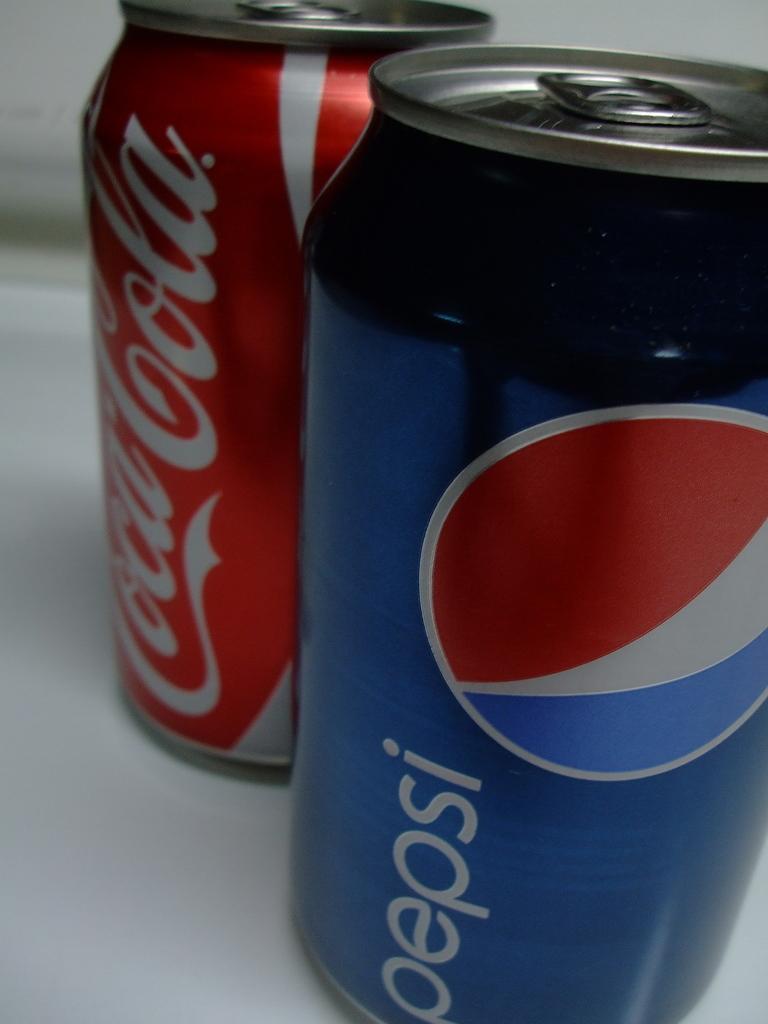What soft drink competes here with pepsi?
Provide a succinct answer. Coca cola. What brand is the blue can?
Your answer should be compact. Pepsi. 